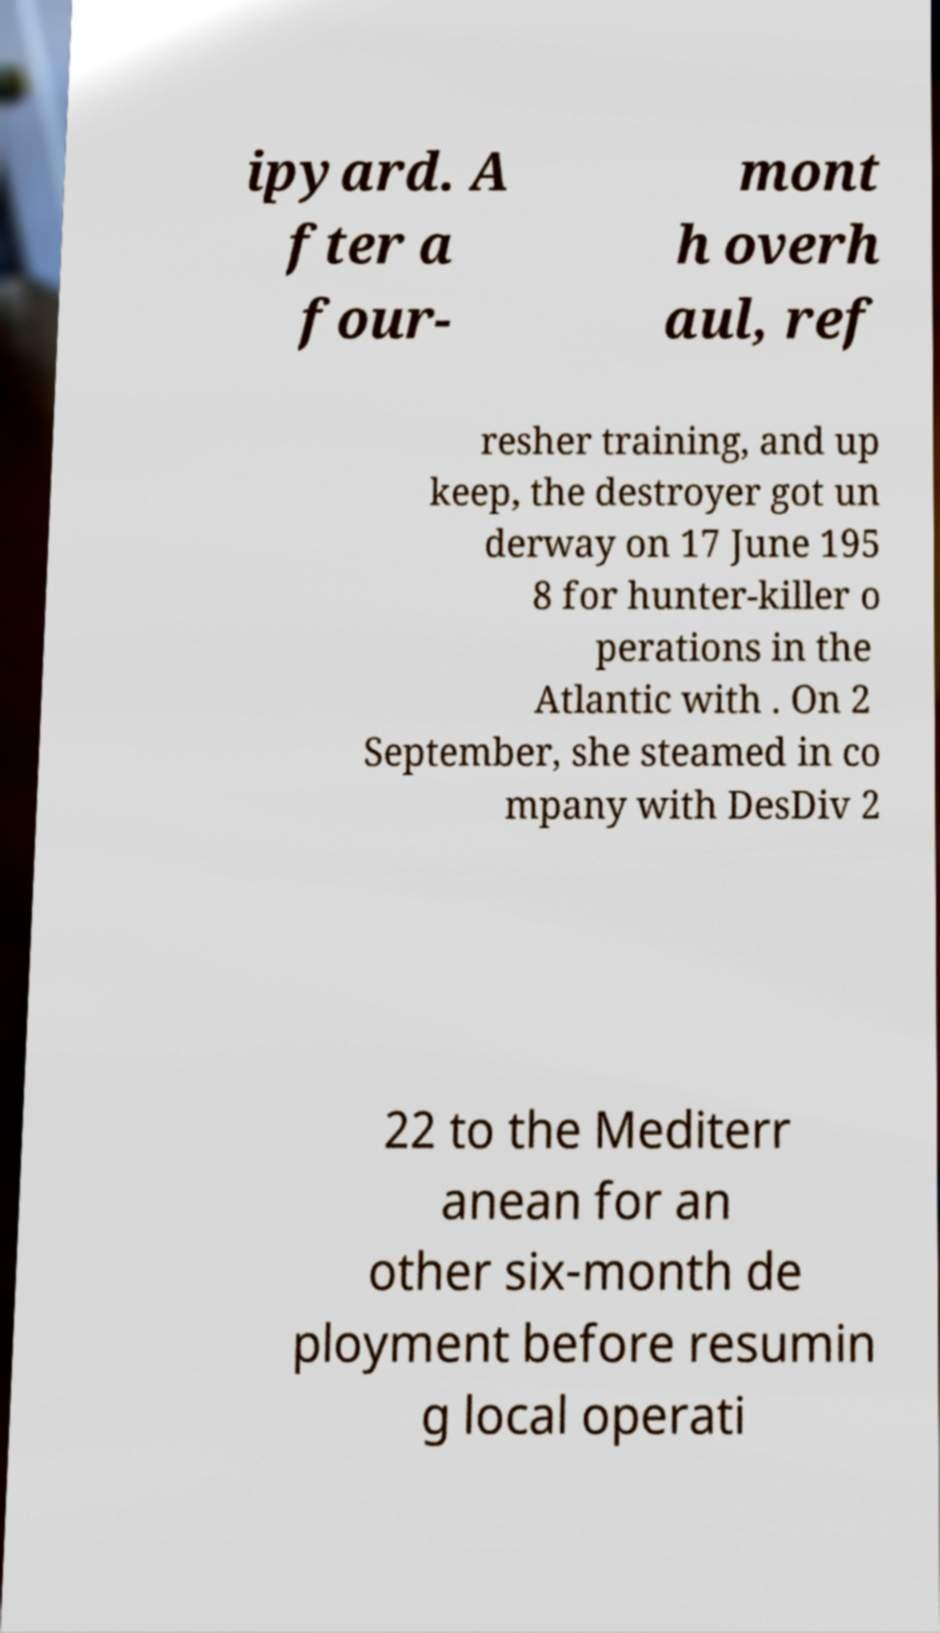Could you extract and type out the text from this image? ipyard. A fter a four- mont h overh aul, ref resher training, and up keep, the destroyer got un derway on 17 June 195 8 for hunter-killer o perations in the Atlantic with . On 2 September, she steamed in co mpany with DesDiv 2 22 to the Mediterr anean for an other six-month de ployment before resumin g local operati 